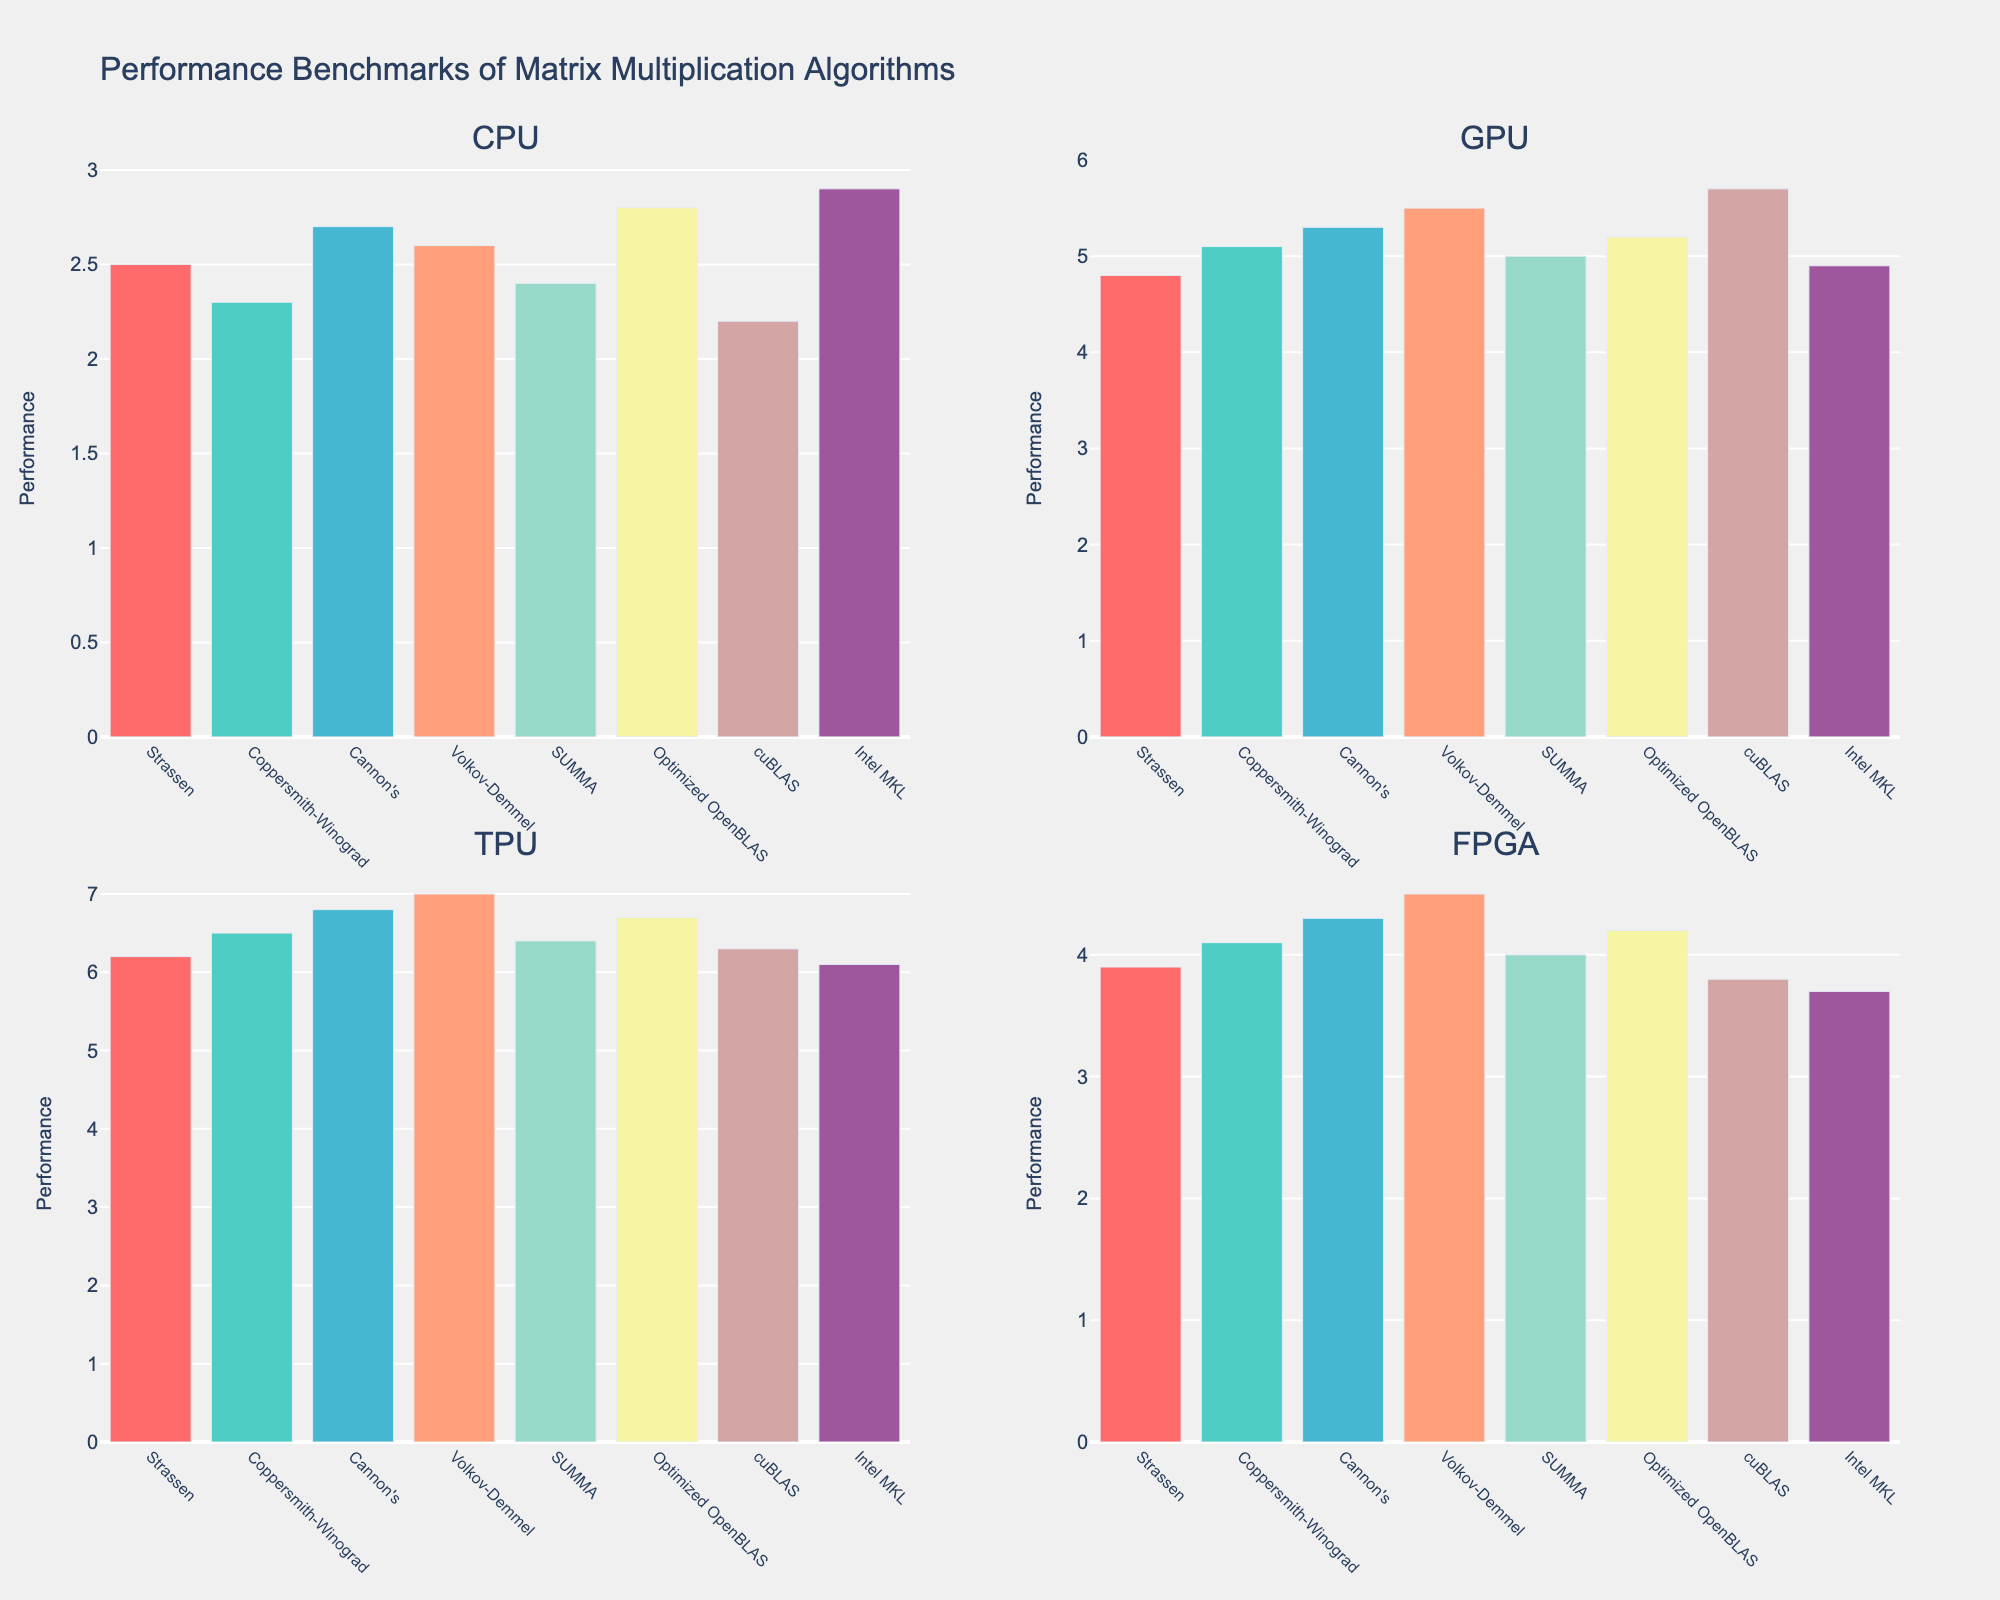What is the performance of the Strassen algorithm on a GPU? The performance of the Strassen algorithm on a GPU can be found in the subplot titled "GPU." There, the bar representing the Strassen algorithm reaches a value of 4.8.
Answer: 4.8 Which algorithm has the highest performance on a TPU? In the TPU subplot, the bar for the Volkov-Demmel algorithm reaches the highest point at 7.0, indicating it has the highest performance.
Answer: Volkov-Demmel How does the performance of Intel MKL on a CPU compare to its performance on a GPU? To compare, look at the Intel MKL bars in the CPU and GPU subplots. The CPU performance is at 2.9, while the GPU performance is at 4.9.
Answer: CPU: 2.9, GPU: 4.9 Which algorithm has the lowest performance on a CPU? In the CPU subplot, the bar for the cuBLAS algorithm is the shortest, indicating a performance value of 2.2, which is the lowest.
Answer: cuBLAS What is the average performance of the SUMMA algorithm across all hardware? Add the performance values of the SUMMA algorithm across CPU (2.4), GPU (5.0), TPU (6.4), and FPGA (4.0) and divide by 4: (2.4 + 5.0 + 6.4 + 4.0) / 4 = 4.45
Answer: 4.45 Which hardware shows the highest overall performance for matrix multiplication algorithms? To determine this, observe the general height of the bars in each subplot. The TPU subplot contains the highest bars on average, indicating the highest overall performance.
Answer: TPU By how much does the performance of the Cannon's algorithm on a GPU exceed its performance on a CPU? Subtract the CPU performance value of Cannon's (2.7) from the GPU performance value (5.3): 5.3 - 2.7 = 2.6
Answer: 2.6 Which algorithm shows the most consistent performance across all hardware types? The optimized OpenBLAS algorithm has values 2.8 (CPU), 5.2 (GPU), 6.7 (TPU), and 4.2 (FPGA). The relative consistency of these values suggests it is the most consistent.
Answer: Optimized OpenBLAS What is the sum of the performance values of the Volkov-Demmel algorithm across all hardware configurations? Add the performance values of Volkov-Demmel across CPU (2.6), GPU (5.5), TPU (7.0), and FPGA (4.5): 2.6 + 5.5 + 7.0 + 4.5 = 19.6
Answer: 19.6 